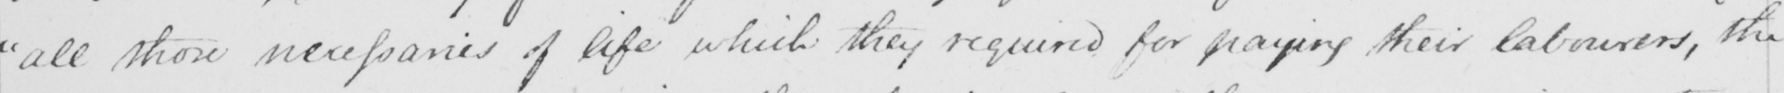Please transcribe the handwritten text in this image. " all those necessaries of life which they required for paying their labourers , the 